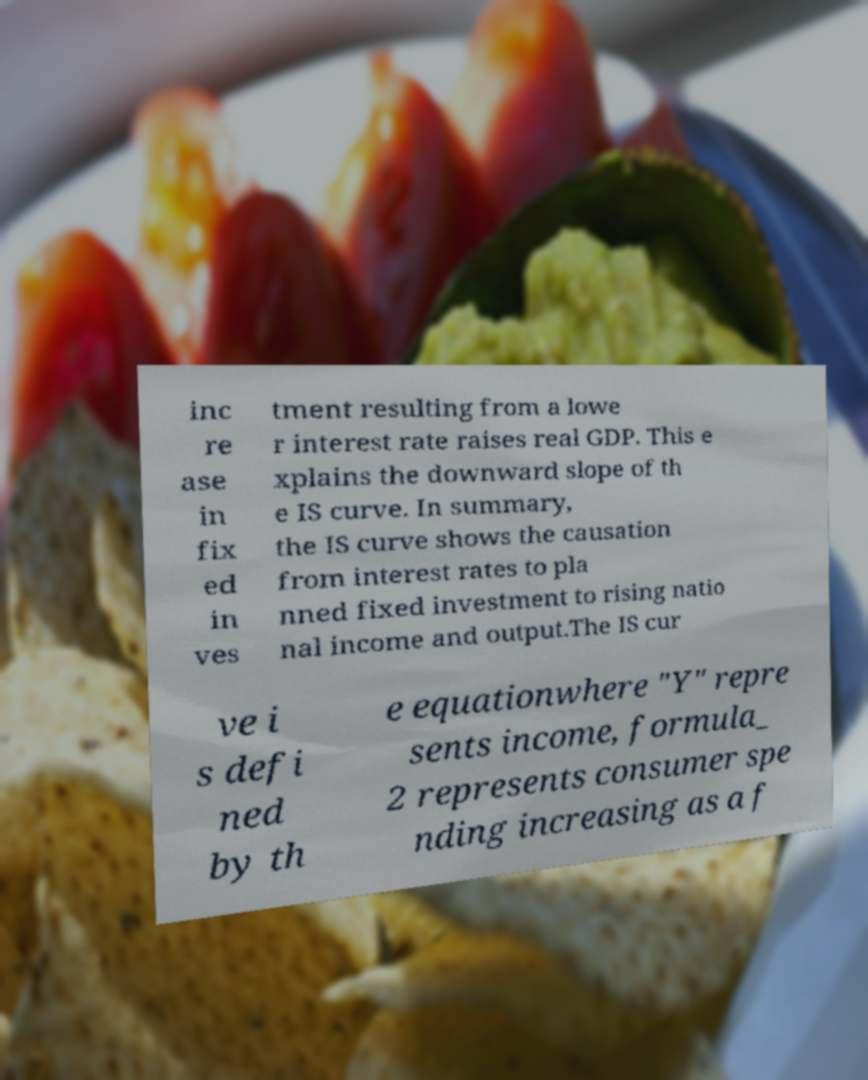What messages or text are displayed in this image? I need them in a readable, typed format. inc re ase in fix ed in ves tment resulting from a lowe r interest rate raises real GDP. This e xplains the downward slope of th e IS curve. In summary, the IS curve shows the causation from interest rates to pla nned fixed investment to rising natio nal income and output.The IS cur ve i s defi ned by th e equationwhere "Y" repre sents income, formula_ 2 represents consumer spe nding increasing as a f 